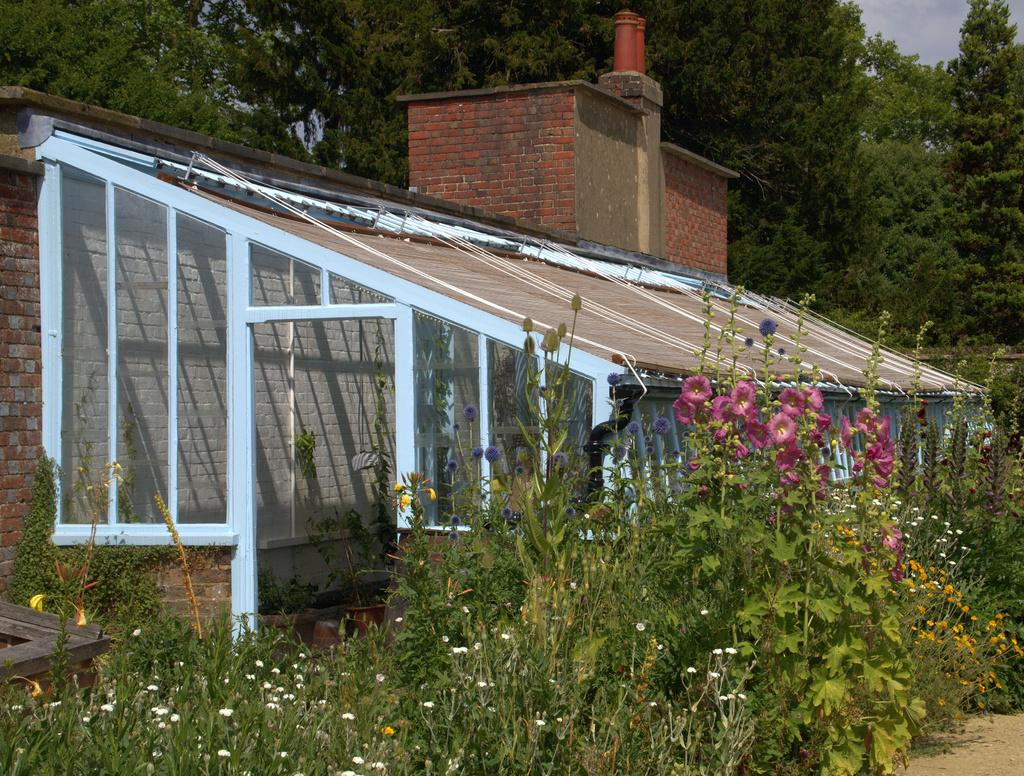What type of plants can be seen in the image? There are plants with flowers in the image. What structure is visible in the image? There is a house in the image. What can be seen in the background of the image? There are trees and the sky visible in the background of the image. Can you describe the friction between the plants and the house in the image? There is no friction between the plants and the house in the image, as they are not interacting with each other. What type of argument is taking place between the plants and the trees in the image? There is no argument between the plants and the trees in the image, as they are not sentient beings capable of having an argument. 